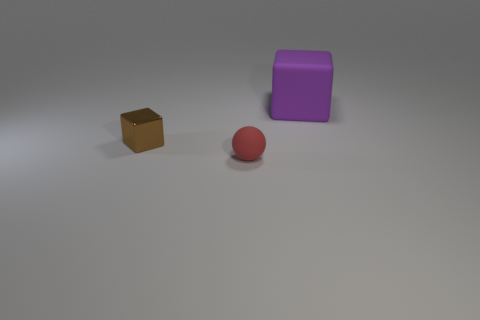Is there anything else that has the same material as the small brown block?
Your answer should be very brief. No. The other object that is the same size as the brown thing is what shape?
Offer a terse response. Sphere. Are there any blocks behind the small brown object?
Ensure brevity in your answer.  Yes. Are there any other things that have the same shape as the brown shiny object?
Your answer should be very brief. Yes. There is a rubber object that is right of the tiny red ball; does it have the same shape as the thing that is left of the red ball?
Offer a very short reply. Yes. Is there a red matte sphere of the same size as the brown shiny cube?
Your answer should be compact. Yes. Are there the same number of red things in front of the tiny shiny block and tiny red balls left of the red rubber thing?
Ensure brevity in your answer.  No. Does the small object that is behind the red sphere have the same material as the large purple cube that is behind the small rubber ball?
Your response must be concise. No. What material is the red sphere?
Make the answer very short. Rubber. How many rubber cylinders are there?
Offer a terse response. 0. 